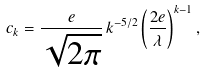Convert formula to latex. <formula><loc_0><loc_0><loc_500><loc_500>c _ { k } = \frac { e } { \sqrt { 2 \pi } } \, k ^ { - 5 / 2 } \left ( \frac { 2 e } { \lambda } \right ) ^ { k - 1 } ,</formula> 